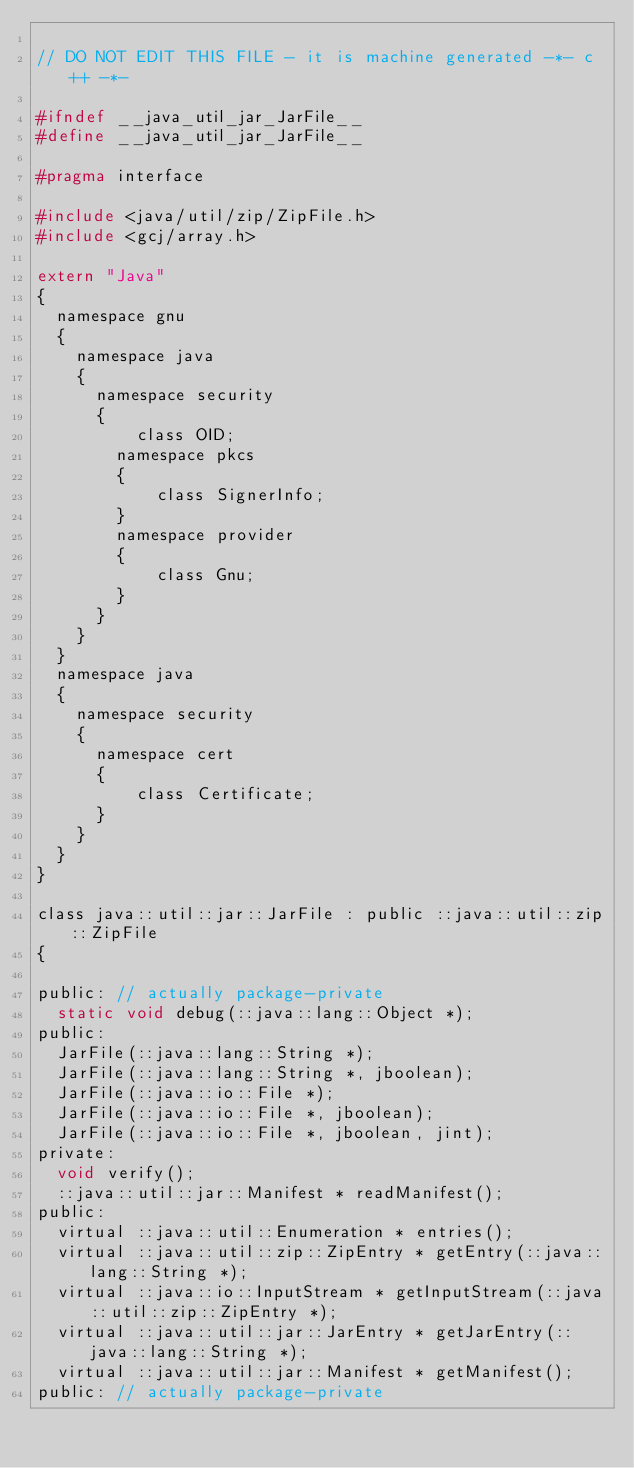Convert code to text. <code><loc_0><loc_0><loc_500><loc_500><_C_>
// DO NOT EDIT THIS FILE - it is machine generated -*- c++ -*-

#ifndef __java_util_jar_JarFile__
#define __java_util_jar_JarFile__

#pragma interface

#include <java/util/zip/ZipFile.h>
#include <gcj/array.h>

extern "Java"
{
  namespace gnu
  {
    namespace java
    {
      namespace security
      {
          class OID;
        namespace pkcs
        {
            class SignerInfo;
        }
        namespace provider
        {
            class Gnu;
        }
      }
    }
  }
  namespace java
  {
    namespace security
    {
      namespace cert
      {
          class Certificate;
      }
    }
  }
}

class java::util::jar::JarFile : public ::java::util::zip::ZipFile
{

public: // actually package-private
  static void debug(::java::lang::Object *);
public:
  JarFile(::java::lang::String *);
  JarFile(::java::lang::String *, jboolean);
  JarFile(::java::io::File *);
  JarFile(::java::io::File *, jboolean);
  JarFile(::java::io::File *, jboolean, jint);
private:
  void verify();
  ::java::util::jar::Manifest * readManifest();
public:
  virtual ::java::util::Enumeration * entries();
  virtual ::java::util::zip::ZipEntry * getEntry(::java::lang::String *);
  virtual ::java::io::InputStream * getInputStream(::java::util::zip::ZipEntry *);
  virtual ::java::util::jar::JarEntry * getJarEntry(::java::lang::String *);
  virtual ::java::util::jar::Manifest * getManifest();
public: // actually package-private</code> 